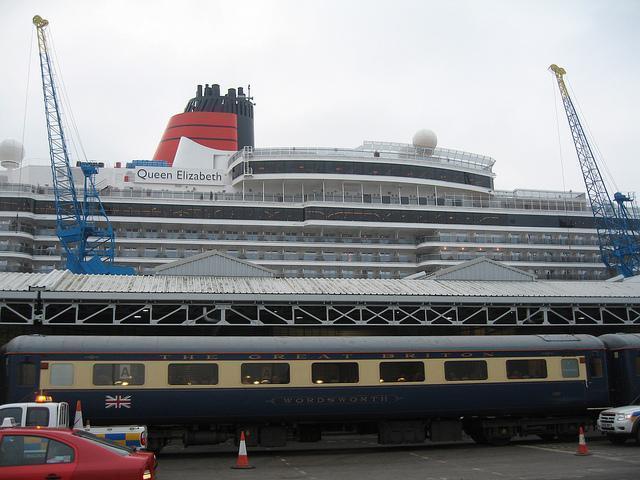How many people are to the immediate left of the motorcycle?
Give a very brief answer. 0. 